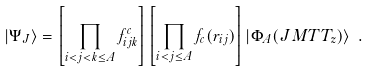<formula> <loc_0><loc_0><loc_500><loc_500>| \Psi _ { J } \rangle = \left [ \prod _ { i < j < k \leq A } f ^ { c } _ { i j k } \right ] \left [ \prod _ { i < j \leq A } f _ { c } ( r _ { i j } ) \right ] | \Phi _ { A } ( J M T T _ { z } ) \rangle \ .</formula> 